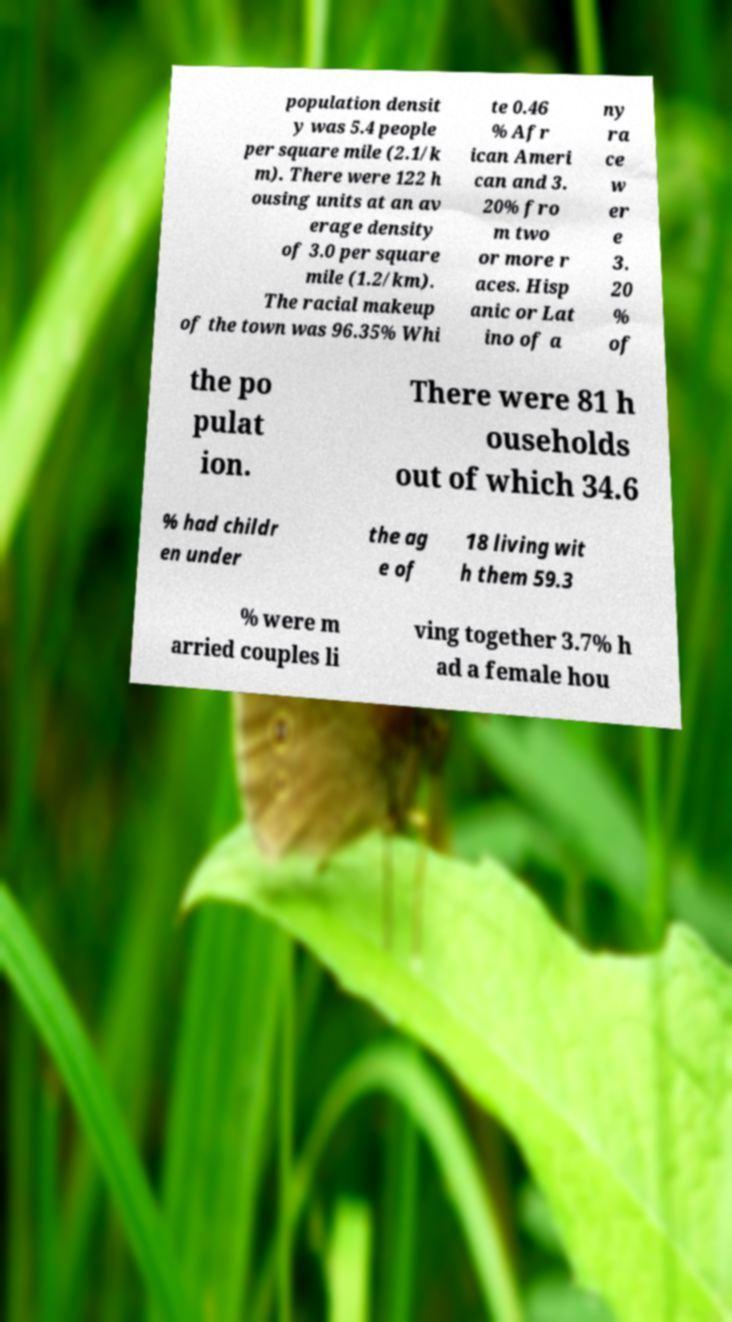Please read and relay the text visible in this image. What does it say? population densit y was 5.4 people per square mile (2.1/k m). There were 122 h ousing units at an av erage density of 3.0 per square mile (1.2/km). The racial makeup of the town was 96.35% Whi te 0.46 % Afr ican Ameri can and 3. 20% fro m two or more r aces. Hisp anic or Lat ino of a ny ra ce w er e 3. 20 % of the po pulat ion. There were 81 h ouseholds out of which 34.6 % had childr en under the ag e of 18 living wit h them 59.3 % were m arried couples li ving together 3.7% h ad a female hou 